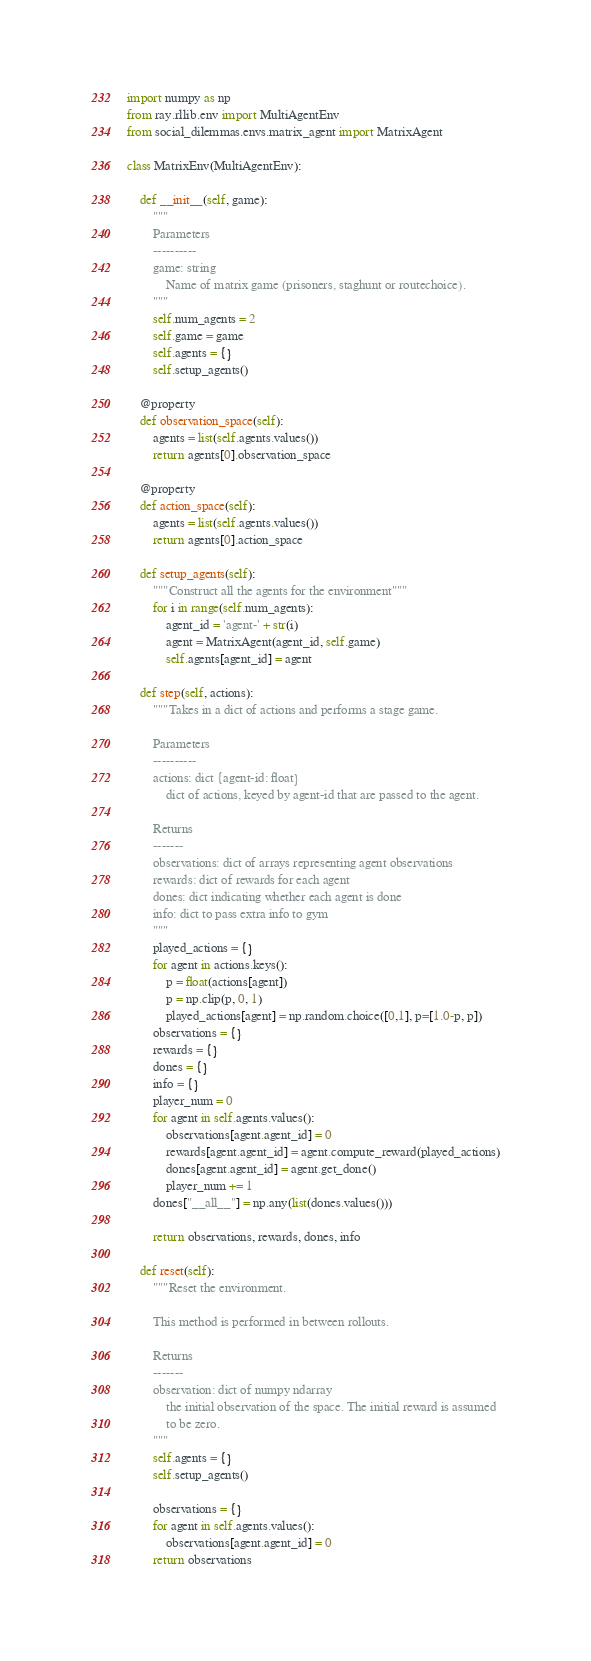Convert code to text. <code><loc_0><loc_0><loc_500><loc_500><_Python_>import numpy as np
from ray.rllib.env import MultiAgentEnv
from social_dilemmas.envs.matrix_agent import MatrixAgent

class MatrixEnv(MultiAgentEnv):

    def __init__(self, game):
        """
        Parameters
        ----------
        game: string
            Name of matrix game (prisoners, staghunt or routechoice).
        """
        self.num_agents = 2
        self.game = game
        self.agents = {}
        self.setup_agents()

    @property
    def observation_space(self):
        agents = list(self.agents.values())
        return agents[0].observation_space

    @property
    def action_space(self):
        agents = list(self.agents.values())
        return agents[0].action_space

    def setup_agents(self):
        """Construct all the agents for the environment"""
        for i in range(self.num_agents):
            agent_id = 'agent-' + str(i)
            agent = MatrixAgent(agent_id, self.game)
            self.agents[agent_id] = agent

    def step(self, actions):
        """Takes in a dict of actions and performs a stage game.

        Parameters
        ----------
        actions: dict {agent-id: float}
            dict of actions, keyed by agent-id that are passed to the agent. 

        Returns
        -------
        observations: dict of arrays representing agent observations
        rewards: dict of rewards for each agent
        dones: dict indicating whether each agent is done
        info: dict to pass extra info to gym
        """
        played_actions = {}
        for agent in actions.keys():
            p = float(actions[agent])
            p = np.clip(p, 0, 1)
            played_actions[agent] = np.random.choice([0,1], p=[1.0-p, p])
        observations = {}
        rewards = {}
        dones = {}
        info = {}
        player_num = 0
        for agent in self.agents.values():
            observations[agent.agent_id] = 0
            rewards[agent.agent_id] = agent.compute_reward(played_actions)
            dones[agent.agent_id] = agent.get_done()
            player_num += 1
        dones["__all__"] = np.any(list(dones.values()))

        return observations, rewards, dones, info

    def reset(self):
        """Reset the environment.

        This method is performed in between rollouts. 

        Returns
        -------
        observation: dict of numpy ndarray
            the initial observation of the space. The initial reward is assumed
            to be zero.
        """
        self.agents = {}
        self.setup_agents()

        observations = {}
        for agent in self.agents.values():
            observations[agent.agent_id] = 0
        return observations
</code> 